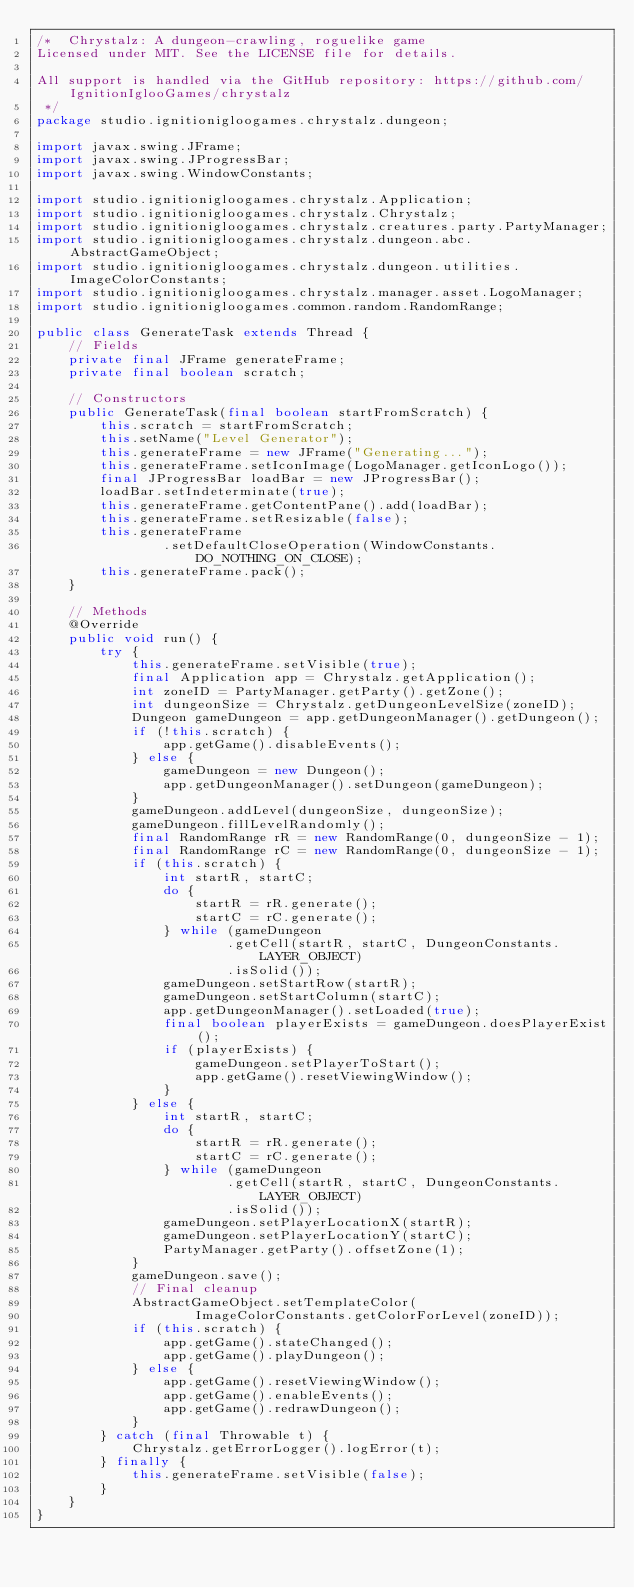Convert code to text. <code><loc_0><loc_0><loc_500><loc_500><_Java_>/*  Chrystalz: A dungeon-crawling, roguelike game
Licensed under MIT. See the LICENSE file for details.

All support is handled via the GitHub repository: https://github.com/IgnitionIglooGames/chrystalz
 */
package studio.ignitionigloogames.chrystalz.dungeon;

import javax.swing.JFrame;
import javax.swing.JProgressBar;
import javax.swing.WindowConstants;

import studio.ignitionigloogames.chrystalz.Application;
import studio.ignitionigloogames.chrystalz.Chrystalz;
import studio.ignitionigloogames.chrystalz.creatures.party.PartyManager;
import studio.ignitionigloogames.chrystalz.dungeon.abc.AbstractGameObject;
import studio.ignitionigloogames.chrystalz.dungeon.utilities.ImageColorConstants;
import studio.ignitionigloogames.chrystalz.manager.asset.LogoManager;
import studio.ignitionigloogames.common.random.RandomRange;

public class GenerateTask extends Thread {
    // Fields
    private final JFrame generateFrame;
    private final boolean scratch;

    // Constructors
    public GenerateTask(final boolean startFromScratch) {
        this.scratch = startFromScratch;
        this.setName("Level Generator");
        this.generateFrame = new JFrame("Generating...");
        this.generateFrame.setIconImage(LogoManager.getIconLogo());
        final JProgressBar loadBar = new JProgressBar();
        loadBar.setIndeterminate(true);
        this.generateFrame.getContentPane().add(loadBar);
        this.generateFrame.setResizable(false);
        this.generateFrame
                .setDefaultCloseOperation(WindowConstants.DO_NOTHING_ON_CLOSE);
        this.generateFrame.pack();
    }

    // Methods
    @Override
    public void run() {
        try {
            this.generateFrame.setVisible(true);
            final Application app = Chrystalz.getApplication();
            int zoneID = PartyManager.getParty().getZone();
            int dungeonSize = Chrystalz.getDungeonLevelSize(zoneID);
            Dungeon gameDungeon = app.getDungeonManager().getDungeon();
            if (!this.scratch) {
                app.getGame().disableEvents();
            } else {
                gameDungeon = new Dungeon();
                app.getDungeonManager().setDungeon(gameDungeon);
            }
            gameDungeon.addLevel(dungeonSize, dungeonSize);
            gameDungeon.fillLevelRandomly();
            final RandomRange rR = new RandomRange(0, dungeonSize - 1);
            final RandomRange rC = new RandomRange(0, dungeonSize - 1);
            if (this.scratch) {
                int startR, startC;
                do {
                    startR = rR.generate();
                    startC = rC.generate();
                } while (gameDungeon
                        .getCell(startR, startC, DungeonConstants.LAYER_OBJECT)
                        .isSolid());
                gameDungeon.setStartRow(startR);
                gameDungeon.setStartColumn(startC);
                app.getDungeonManager().setLoaded(true);
                final boolean playerExists = gameDungeon.doesPlayerExist();
                if (playerExists) {
                    gameDungeon.setPlayerToStart();
                    app.getGame().resetViewingWindow();
                }
            } else {
                int startR, startC;
                do {
                    startR = rR.generate();
                    startC = rC.generate();
                } while (gameDungeon
                        .getCell(startR, startC, DungeonConstants.LAYER_OBJECT)
                        .isSolid());
                gameDungeon.setPlayerLocationX(startR);
                gameDungeon.setPlayerLocationY(startC);
                PartyManager.getParty().offsetZone(1);
            }
            gameDungeon.save();
            // Final cleanup
            AbstractGameObject.setTemplateColor(
                    ImageColorConstants.getColorForLevel(zoneID));
            if (this.scratch) {
                app.getGame().stateChanged();
                app.getGame().playDungeon();
            } else {
                app.getGame().resetViewingWindow();
                app.getGame().enableEvents();
                app.getGame().redrawDungeon();
            }
        } catch (final Throwable t) {
            Chrystalz.getErrorLogger().logError(t);
        } finally {
            this.generateFrame.setVisible(false);
        }
    }
}
</code> 